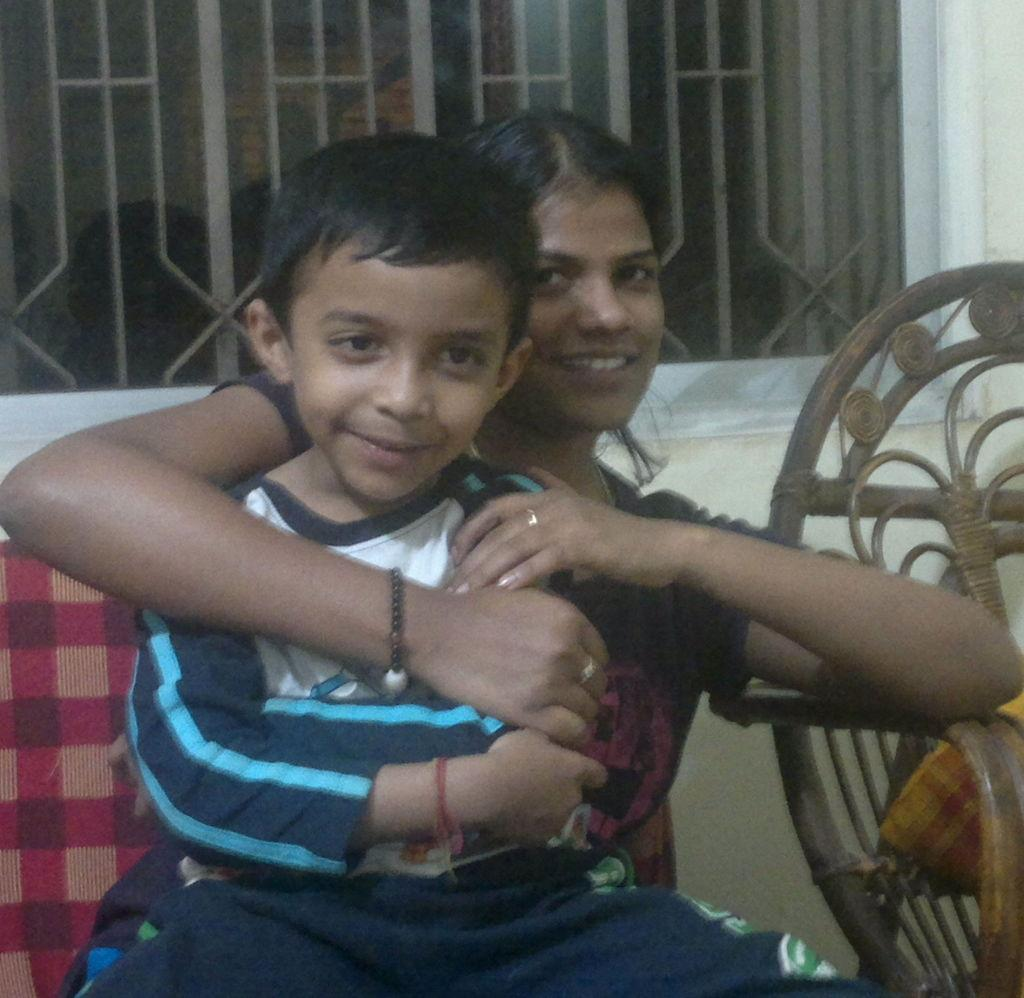How many people are present in the image? There are two people sitting on chairs in the image. What can be seen in the background of the image? There is a wall with a window in the background of the image. What type of sponge is being used by the people in the image? There is no sponge present in the image; the people are simply sitting on chairs. 